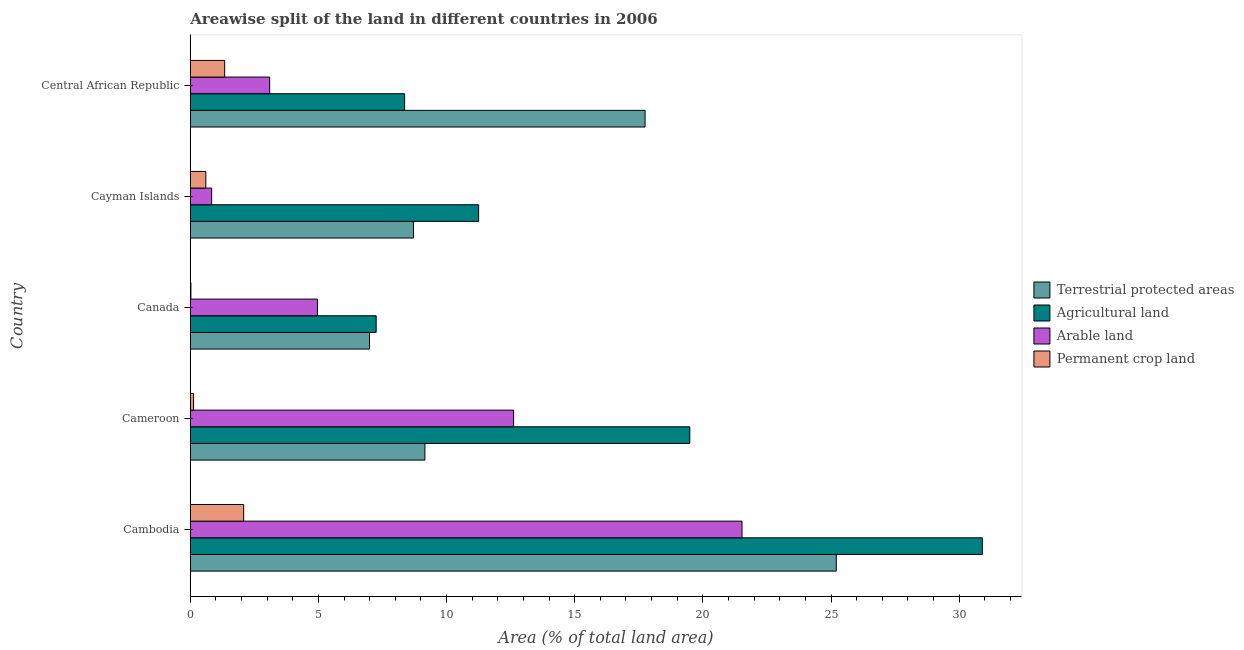Are the number of bars per tick equal to the number of legend labels?
Provide a short and direct response. Yes. Are the number of bars on each tick of the Y-axis equal?
Provide a succinct answer. Yes. What is the label of the 3rd group of bars from the top?
Make the answer very short. Canada. What is the percentage of area under arable land in Cameroon?
Provide a short and direct response. 12.61. Across all countries, what is the maximum percentage of land under terrestrial protection?
Provide a succinct answer. 25.21. Across all countries, what is the minimum percentage of area under permanent crop land?
Offer a very short reply. 0.02. In which country was the percentage of area under permanent crop land maximum?
Your answer should be compact. Cambodia. In which country was the percentage of area under arable land minimum?
Keep it short and to the point. Cayman Islands. What is the total percentage of area under arable land in the graph?
Keep it short and to the point. 43.03. What is the difference between the percentage of land under terrestrial protection in Cameroon and that in Cayman Islands?
Provide a succinct answer. 0.44. What is the difference between the percentage of area under arable land in Cameroon and the percentage of area under agricultural land in Central African Republic?
Make the answer very short. 4.25. What is the average percentage of land under terrestrial protection per country?
Offer a terse response. 13.56. What is the difference between the percentage of area under arable land and percentage of area under agricultural land in Canada?
Keep it short and to the point. -2.29. What is the ratio of the percentage of land under terrestrial protection in Cambodia to that in Cayman Islands?
Give a very brief answer. 2.89. What is the difference between the highest and the second highest percentage of land under terrestrial protection?
Your response must be concise. 7.46. What is the difference between the highest and the lowest percentage of area under permanent crop land?
Ensure brevity in your answer.  2.06. In how many countries, is the percentage of area under arable land greater than the average percentage of area under arable land taken over all countries?
Your answer should be very brief. 2. Is it the case that in every country, the sum of the percentage of area under agricultural land and percentage of land under terrestrial protection is greater than the sum of percentage of area under permanent crop land and percentage of area under arable land?
Offer a very short reply. No. What does the 4th bar from the top in Canada represents?
Offer a terse response. Terrestrial protected areas. What does the 4th bar from the bottom in Cayman Islands represents?
Keep it short and to the point. Permanent crop land. What is the difference between two consecutive major ticks on the X-axis?
Give a very brief answer. 5. Are the values on the major ticks of X-axis written in scientific E-notation?
Make the answer very short. No. Does the graph contain grids?
Offer a very short reply. No. Where does the legend appear in the graph?
Keep it short and to the point. Center right. How many legend labels are there?
Your answer should be very brief. 4. How are the legend labels stacked?
Give a very brief answer. Vertical. What is the title of the graph?
Offer a very short reply. Areawise split of the land in different countries in 2006. What is the label or title of the X-axis?
Give a very brief answer. Area (% of total land area). What is the Area (% of total land area) of Terrestrial protected areas in Cambodia?
Your answer should be compact. 25.21. What is the Area (% of total land area) of Agricultural land in Cambodia?
Your response must be concise. 30.9. What is the Area (% of total land area) of Arable land in Cambodia?
Ensure brevity in your answer.  21.53. What is the Area (% of total land area) of Permanent crop land in Cambodia?
Provide a succinct answer. 2.08. What is the Area (% of total land area) of Terrestrial protected areas in Cameroon?
Provide a succinct answer. 9.15. What is the Area (% of total land area) in Agricultural land in Cameroon?
Your answer should be compact. 19.49. What is the Area (% of total land area) in Arable land in Cameroon?
Provide a succinct answer. 12.61. What is the Area (% of total land area) of Permanent crop land in Cameroon?
Give a very brief answer. 0.13. What is the Area (% of total land area) in Terrestrial protected areas in Canada?
Make the answer very short. 6.99. What is the Area (% of total land area) of Agricultural land in Canada?
Keep it short and to the point. 7.25. What is the Area (% of total land area) in Arable land in Canada?
Offer a terse response. 4.96. What is the Area (% of total land area) in Permanent crop land in Canada?
Give a very brief answer. 0.02. What is the Area (% of total land area) of Terrestrial protected areas in Cayman Islands?
Offer a terse response. 8.71. What is the Area (% of total land area) in Agricultural land in Cayman Islands?
Keep it short and to the point. 11.25. What is the Area (% of total land area) of Arable land in Cayman Islands?
Your response must be concise. 0.83. What is the Area (% of total land area) of Permanent crop land in Cayman Islands?
Provide a short and direct response. 0.61. What is the Area (% of total land area) of Terrestrial protected areas in Central African Republic?
Offer a very short reply. 17.74. What is the Area (% of total land area) in Agricultural land in Central African Republic?
Provide a short and direct response. 8.36. What is the Area (% of total land area) in Arable land in Central African Republic?
Your response must be concise. 3.1. What is the Area (% of total land area) in Permanent crop land in Central African Republic?
Make the answer very short. 1.34. Across all countries, what is the maximum Area (% of total land area) of Terrestrial protected areas?
Ensure brevity in your answer.  25.21. Across all countries, what is the maximum Area (% of total land area) of Agricultural land?
Provide a short and direct response. 30.9. Across all countries, what is the maximum Area (% of total land area) of Arable land?
Offer a very short reply. 21.53. Across all countries, what is the maximum Area (% of total land area) of Permanent crop land?
Your answer should be very brief. 2.08. Across all countries, what is the minimum Area (% of total land area) of Terrestrial protected areas?
Provide a succinct answer. 6.99. Across all countries, what is the minimum Area (% of total land area) of Agricultural land?
Offer a very short reply. 7.25. Across all countries, what is the minimum Area (% of total land area) in Arable land?
Keep it short and to the point. 0.83. Across all countries, what is the minimum Area (% of total land area) in Permanent crop land?
Make the answer very short. 0.02. What is the total Area (% of total land area) of Terrestrial protected areas in the graph?
Make the answer very short. 67.81. What is the total Area (% of total land area) of Agricultural land in the graph?
Offer a very short reply. 77.26. What is the total Area (% of total land area) of Arable land in the graph?
Ensure brevity in your answer.  43.03. What is the total Area (% of total land area) of Permanent crop land in the graph?
Your answer should be compact. 4.18. What is the difference between the Area (% of total land area) in Terrestrial protected areas in Cambodia and that in Cameroon?
Provide a short and direct response. 16.05. What is the difference between the Area (% of total land area) of Agricultural land in Cambodia and that in Cameroon?
Give a very brief answer. 11.41. What is the difference between the Area (% of total land area) of Arable land in Cambodia and that in Cameroon?
Your answer should be compact. 8.91. What is the difference between the Area (% of total land area) in Permanent crop land in Cambodia and that in Cameroon?
Make the answer very short. 1.95. What is the difference between the Area (% of total land area) of Terrestrial protected areas in Cambodia and that in Canada?
Keep it short and to the point. 18.21. What is the difference between the Area (% of total land area) of Agricultural land in Cambodia and that in Canada?
Keep it short and to the point. 23.65. What is the difference between the Area (% of total land area) in Arable land in Cambodia and that in Canada?
Your answer should be very brief. 16.57. What is the difference between the Area (% of total land area) of Permanent crop land in Cambodia and that in Canada?
Your answer should be compact. 2.06. What is the difference between the Area (% of total land area) of Terrestrial protected areas in Cambodia and that in Cayman Islands?
Give a very brief answer. 16.5. What is the difference between the Area (% of total land area) in Agricultural land in Cambodia and that in Cayman Islands?
Give a very brief answer. 19.65. What is the difference between the Area (% of total land area) in Arable land in Cambodia and that in Cayman Islands?
Ensure brevity in your answer.  20.69. What is the difference between the Area (% of total land area) in Permanent crop land in Cambodia and that in Cayman Islands?
Keep it short and to the point. 1.48. What is the difference between the Area (% of total land area) in Terrestrial protected areas in Cambodia and that in Central African Republic?
Your answer should be compact. 7.46. What is the difference between the Area (% of total land area) of Agricultural land in Cambodia and that in Central African Republic?
Your response must be concise. 22.54. What is the difference between the Area (% of total land area) in Arable land in Cambodia and that in Central African Republic?
Give a very brief answer. 18.43. What is the difference between the Area (% of total land area) in Permanent crop land in Cambodia and that in Central African Republic?
Your answer should be very brief. 0.74. What is the difference between the Area (% of total land area) of Terrestrial protected areas in Cameroon and that in Canada?
Your answer should be compact. 2.16. What is the difference between the Area (% of total land area) of Agricultural land in Cameroon and that in Canada?
Offer a terse response. 12.24. What is the difference between the Area (% of total land area) in Arable land in Cameroon and that in Canada?
Give a very brief answer. 7.65. What is the difference between the Area (% of total land area) of Permanent crop land in Cameroon and that in Canada?
Give a very brief answer. 0.1. What is the difference between the Area (% of total land area) of Terrestrial protected areas in Cameroon and that in Cayman Islands?
Provide a succinct answer. 0.44. What is the difference between the Area (% of total land area) in Agricultural land in Cameroon and that in Cayman Islands?
Your response must be concise. 8.24. What is the difference between the Area (% of total land area) in Arable land in Cameroon and that in Cayman Islands?
Offer a terse response. 11.78. What is the difference between the Area (% of total land area) in Permanent crop land in Cameroon and that in Cayman Islands?
Provide a succinct answer. -0.48. What is the difference between the Area (% of total land area) of Terrestrial protected areas in Cameroon and that in Central African Republic?
Your response must be concise. -8.59. What is the difference between the Area (% of total land area) of Agricultural land in Cameroon and that in Central African Republic?
Offer a terse response. 11.13. What is the difference between the Area (% of total land area) of Arable land in Cameroon and that in Central African Republic?
Make the answer very short. 9.52. What is the difference between the Area (% of total land area) in Permanent crop land in Cameroon and that in Central African Republic?
Your answer should be compact. -1.21. What is the difference between the Area (% of total land area) of Terrestrial protected areas in Canada and that in Cayman Islands?
Offer a terse response. -1.72. What is the difference between the Area (% of total land area) of Agricultural land in Canada and that in Cayman Islands?
Provide a short and direct response. -4. What is the difference between the Area (% of total land area) in Arable land in Canada and that in Cayman Islands?
Your response must be concise. 4.13. What is the difference between the Area (% of total land area) in Permanent crop land in Canada and that in Cayman Islands?
Offer a terse response. -0.58. What is the difference between the Area (% of total land area) in Terrestrial protected areas in Canada and that in Central African Republic?
Make the answer very short. -10.75. What is the difference between the Area (% of total land area) in Agricultural land in Canada and that in Central African Republic?
Your answer should be very brief. -1.11. What is the difference between the Area (% of total land area) in Arable land in Canada and that in Central African Republic?
Your response must be concise. 1.86. What is the difference between the Area (% of total land area) in Permanent crop land in Canada and that in Central African Republic?
Your answer should be compact. -1.32. What is the difference between the Area (% of total land area) in Terrestrial protected areas in Cayman Islands and that in Central African Republic?
Your answer should be compact. -9.03. What is the difference between the Area (% of total land area) of Agricultural land in Cayman Islands and that in Central African Republic?
Give a very brief answer. 2.89. What is the difference between the Area (% of total land area) in Arable land in Cayman Islands and that in Central African Republic?
Provide a succinct answer. -2.26. What is the difference between the Area (% of total land area) in Permanent crop land in Cayman Islands and that in Central African Republic?
Give a very brief answer. -0.74. What is the difference between the Area (% of total land area) in Terrestrial protected areas in Cambodia and the Area (% of total land area) in Agricultural land in Cameroon?
Provide a short and direct response. 5.72. What is the difference between the Area (% of total land area) of Terrestrial protected areas in Cambodia and the Area (% of total land area) of Arable land in Cameroon?
Offer a very short reply. 12.59. What is the difference between the Area (% of total land area) of Terrestrial protected areas in Cambodia and the Area (% of total land area) of Permanent crop land in Cameroon?
Your answer should be very brief. 25.08. What is the difference between the Area (% of total land area) in Agricultural land in Cambodia and the Area (% of total land area) in Arable land in Cameroon?
Make the answer very short. 18.29. What is the difference between the Area (% of total land area) of Agricultural land in Cambodia and the Area (% of total land area) of Permanent crop land in Cameroon?
Offer a very short reply. 30.77. What is the difference between the Area (% of total land area) in Arable land in Cambodia and the Area (% of total land area) in Permanent crop land in Cameroon?
Offer a very short reply. 21.4. What is the difference between the Area (% of total land area) of Terrestrial protected areas in Cambodia and the Area (% of total land area) of Agricultural land in Canada?
Offer a very short reply. 17.95. What is the difference between the Area (% of total land area) in Terrestrial protected areas in Cambodia and the Area (% of total land area) in Arable land in Canada?
Make the answer very short. 20.25. What is the difference between the Area (% of total land area) of Terrestrial protected areas in Cambodia and the Area (% of total land area) of Permanent crop land in Canada?
Your answer should be compact. 25.18. What is the difference between the Area (% of total land area) of Agricultural land in Cambodia and the Area (% of total land area) of Arable land in Canada?
Your answer should be compact. 25.94. What is the difference between the Area (% of total land area) of Agricultural land in Cambodia and the Area (% of total land area) of Permanent crop land in Canada?
Your response must be concise. 30.88. What is the difference between the Area (% of total land area) in Arable land in Cambodia and the Area (% of total land area) in Permanent crop land in Canada?
Your response must be concise. 21.5. What is the difference between the Area (% of total land area) in Terrestrial protected areas in Cambodia and the Area (% of total land area) in Agricultural land in Cayman Islands?
Make the answer very short. 13.96. What is the difference between the Area (% of total land area) of Terrestrial protected areas in Cambodia and the Area (% of total land area) of Arable land in Cayman Islands?
Keep it short and to the point. 24.37. What is the difference between the Area (% of total land area) of Terrestrial protected areas in Cambodia and the Area (% of total land area) of Permanent crop land in Cayman Islands?
Provide a short and direct response. 24.6. What is the difference between the Area (% of total land area) of Agricultural land in Cambodia and the Area (% of total land area) of Arable land in Cayman Islands?
Offer a very short reply. 30.07. What is the difference between the Area (% of total land area) in Agricultural land in Cambodia and the Area (% of total land area) in Permanent crop land in Cayman Islands?
Offer a terse response. 30.3. What is the difference between the Area (% of total land area) in Arable land in Cambodia and the Area (% of total land area) in Permanent crop land in Cayman Islands?
Offer a very short reply. 20.92. What is the difference between the Area (% of total land area) in Terrestrial protected areas in Cambodia and the Area (% of total land area) in Agricultural land in Central African Republic?
Give a very brief answer. 16.84. What is the difference between the Area (% of total land area) in Terrestrial protected areas in Cambodia and the Area (% of total land area) in Arable land in Central African Republic?
Your response must be concise. 22.11. What is the difference between the Area (% of total land area) of Terrestrial protected areas in Cambodia and the Area (% of total land area) of Permanent crop land in Central African Republic?
Your answer should be compact. 23.86. What is the difference between the Area (% of total land area) of Agricultural land in Cambodia and the Area (% of total land area) of Arable land in Central African Republic?
Give a very brief answer. 27.8. What is the difference between the Area (% of total land area) in Agricultural land in Cambodia and the Area (% of total land area) in Permanent crop land in Central African Republic?
Make the answer very short. 29.56. What is the difference between the Area (% of total land area) in Arable land in Cambodia and the Area (% of total land area) in Permanent crop land in Central African Republic?
Your answer should be very brief. 20.19. What is the difference between the Area (% of total land area) in Terrestrial protected areas in Cameroon and the Area (% of total land area) in Agricultural land in Canada?
Provide a succinct answer. 1.9. What is the difference between the Area (% of total land area) of Terrestrial protected areas in Cameroon and the Area (% of total land area) of Arable land in Canada?
Offer a terse response. 4.19. What is the difference between the Area (% of total land area) in Terrestrial protected areas in Cameroon and the Area (% of total land area) in Permanent crop land in Canada?
Provide a succinct answer. 9.13. What is the difference between the Area (% of total land area) of Agricultural land in Cameroon and the Area (% of total land area) of Arable land in Canada?
Your answer should be compact. 14.53. What is the difference between the Area (% of total land area) of Agricultural land in Cameroon and the Area (% of total land area) of Permanent crop land in Canada?
Provide a short and direct response. 19.47. What is the difference between the Area (% of total land area) in Arable land in Cameroon and the Area (% of total land area) in Permanent crop land in Canada?
Offer a terse response. 12.59. What is the difference between the Area (% of total land area) in Terrestrial protected areas in Cameroon and the Area (% of total land area) in Agricultural land in Cayman Islands?
Keep it short and to the point. -2.1. What is the difference between the Area (% of total land area) in Terrestrial protected areas in Cameroon and the Area (% of total land area) in Arable land in Cayman Islands?
Your answer should be compact. 8.32. What is the difference between the Area (% of total land area) of Terrestrial protected areas in Cameroon and the Area (% of total land area) of Permanent crop land in Cayman Islands?
Your response must be concise. 8.55. What is the difference between the Area (% of total land area) in Agricultural land in Cameroon and the Area (% of total land area) in Arable land in Cayman Islands?
Give a very brief answer. 18.66. What is the difference between the Area (% of total land area) in Agricultural land in Cameroon and the Area (% of total land area) in Permanent crop land in Cayman Islands?
Your response must be concise. 18.88. What is the difference between the Area (% of total land area) of Arable land in Cameroon and the Area (% of total land area) of Permanent crop land in Cayman Islands?
Your answer should be compact. 12.01. What is the difference between the Area (% of total land area) of Terrestrial protected areas in Cameroon and the Area (% of total land area) of Agricultural land in Central African Republic?
Give a very brief answer. 0.79. What is the difference between the Area (% of total land area) of Terrestrial protected areas in Cameroon and the Area (% of total land area) of Arable land in Central African Republic?
Give a very brief answer. 6.06. What is the difference between the Area (% of total land area) of Terrestrial protected areas in Cameroon and the Area (% of total land area) of Permanent crop land in Central African Republic?
Provide a succinct answer. 7.81. What is the difference between the Area (% of total land area) in Agricultural land in Cameroon and the Area (% of total land area) in Arable land in Central African Republic?
Keep it short and to the point. 16.39. What is the difference between the Area (% of total land area) in Agricultural land in Cameroon and the Area (% of total land area) in Permanent crop land in Central African Republic?
Your answer should be compact. 18.15. What is the difference between the Area (% of total land area) in Arable land in Cameroon and the Area (% of total land area) in Permanent crop land in Central African Republic?
Offer a very short reply. 11.27. What is the difference between the Area (% of total land area) of Terrestrial protected areas in Canada and the Area (% of total land area) of Agricultural land in Cayman Islands?
Your answer should be very brief. -4.26. What is the difference between the Area (% of total land area) of Terrestrial protected areas in Canada and the Area (% of total land area) of Arable land in Cayman Islands?
Provide a succinct answer. 6.16. What is the difference between the Area (% of total land area) of Terrestrial protected areas in Canada and the Area (% of total land area) of Permanent crop land in Cayman Islands?
Ensure brevity in your answer.  6.39. What is the difference between the Area (% of total land area) in Agricultural land in Canada and the Area (% of total land area) in Arable land in Cayman Islands?
Keep it short and to the point. 6.42. What is the difference between the Area (% of total land area) in Agricultural land in Canada and the Area (% of total land area) in Permanent crop land in Cayman Islands?
Keep it short and to the point. 6.65. What is the difference between the Area (% of total land area) of Arable land in Canada and the Area (% of total land area) of Permanent crop land in Cayman Islands?
Keep it short and to the point. 4.36. What is the difference between the Area (% of total land area) of Terrestrial protected areas in Canada and the Area (% of total land area) of Agricultural land in Central African Republic?
Offer a terse response. -1.37. What is the difference between the Area (% of total land area) in Terrestrial protected areas in Canada and the Area (% of total land area) in Arable land in Central African Republic?
Offer a very short reply. 3.89. What is the difference between the Area (% of total land area) in Terrestrial protected areas in Canada and the Area (% of total land area) in Permanent crop land in Central African Republic?
Offer a very short reply. 5.65. What is the difference between the Area (% of total land area) of Agricultural land in Canada and the Area (% of total land area) of Arable land in Central African Republic?
Offer a very short reply. 4.15. What is the difference between the Area (% of total land area) in Agricultural land in Canada and the Area (% of total land area) in Permanent crop land in Central African Republic?
Your answer should be compact. 5.91. What is the difference between the Area (% of total land area) of Arable land in Canada and the Area (% of total land area) of Permanent crop land in Central African Republic?
Keep it short and to the point. 3.62. What is the difference between the Area (% of total land area) in Terrestrial protected areas in Cayman Islands and the Area (% of total land area) in Agricultural land in Central African Republic?
Keep it short and to the point. 0.35. What is the difference between the Area (% of total land area) of Terrestrial protected areas in Cayman Islands and the Area (% of total land area) of Arable land in Central African Republic?
Offer a terse response. 5.61. What is the difference between the Area (% of total land area) in Terrestrial protected areas in Cayman Islands and the Area (% of total land area) in Permanent crop land in Central African Republic?
Ensure brevity in your answer.  7.37. What is the difference between the Area (% of total land area) of Agricultural land in Cayman Islands and the Area (% of total land area) of Arable land in Central African Republic?
Provide a short and direct response. 8.15. What is the difference between the Area (% of total land area) in Agricultural land in Cayman Islands and the Area (% of total land area) in Permanent crop land in Central African Republic?
Keep it short and to the point. 9.91. What is the difference between the Area (% of total land area) in Arable land in Cayman Islands and the Area (% of total land area) in Permanent crop land in Central African Republic?
Provide a succinct answer. -0.51. What is the average Area (% of total land area) in Terrestrial protected areas per country?
Give a very brief answer. 13.56. What is the average Area (% of total land area) in Agricultural land per country?
Make the answer very short. 15.45. What is the average Area (% of total land area) in Arable land per country?
Provide a short and direct response. 8.61. What is the average Area (% of total land area) of Permanent crop land per country?
Provide a short and direct response. 0.84. What is the difference between the Area (% of total land area) of Terrestrial protected areas and Area (% of total land area) of Agricultural land in Cambodia?
Your answer should be very brief. -5.7. What is the difference between the Area (% of total land area) of Terrestrial protected areas and Area (% of total land area) of Arable land in Cambodia?
Your answer should be very brief. 3.68. What is the difference between the Area (% of total land area) of Terrestrial protected areas and Area (% of total land area) of Permanent crop land in Cambodia?
Provide a short and direct response. 23.12. What is the difference between the Area (% of total land area) of Agricultural land and Area (% of total land area) of Arable land in Cambodia?
Give a very brief answer. 9.38. What is the difference between the Area (% of total land area) in Agricultural land and Area (% of total land area) in Permanent crop land in Cambodia?
Keep it short and to the point. 28.82. What is the difference between the Area (% of total land area) of Arable land and Area (% of total land area) of Permanent crop land in Cambodia?
Ensure brevity in your answer.  19.44. What is the difference between the Area (% of total land area) of Terrestrial protected areas and Area (% of total land area) of Agricultural land in Cameroon?
Your answer should be compact. -10.34. What is the difference between the Area (% of total land area) of Terrestrial protected areas and Area (% of total land area) of Arable land in Cameroon?
Provide a succinct answer. -3.46. What is the difference between the Area (% of total land area) in Terrestrial protected areas and Area (% of total land area) in Permanent crop land in Cameroon?
Provide a succinct answer. 9.03. What is the difference between the Area (% of total land area) in Agricultural land and Area (% of total land area) in Arable land in Cameroon?
Offer a very short reply. 6.88. What is the difference between the Area (% of total land area) in Agricultural land and Area (% of total land area) in Permanent crop land in Cameroon?
Offer a terse response. 19.36. What is the difference between the Area (% of total land area) of Arable land and Area (% of total land area) of Permanent crop land in Cameroon?
Provide a succinct answer. 12.49. What is the difference between the Area (% of total land area) in Terrestrial protected areas and Area (% of total land area) in Agricultural land in Canada?
Offer a terse response. -0.26. What is the difference between the Area (% of total land area) in Terrestrial protected areas and Area (% of total land area) in Arable land in Canada?
Your answer should be compact. 2.03. What is the difference between the Area (% of total land area) of Terrestrial protected areas and Area (% of total land area) of Permanent crop land in Canada?
Your answer should be compact. 6.97. What is the difference between the Area (% of total land area) of Agricultural land and Area (% of total land area) of Arable land in Canada?
Keep it short and to the point. 2.29. What is the difference between the Area (% of total land area) in Agricultural land and Area (% of total land area) in Permanent crop land in Canada?
Offer a very short reply. 7.23. What is the difference between the Area (% of total land area) of Arable land and Area (% of total land area) of Permanent crop land in Canada?
Your response must be concise. 4.94. What is the difference between the Area (% of total land area) of Terrestrial protected areas and Area (% of total land area) of Agricultural land in Cayman Islands?
Make the answer very short. -2.54. What is the difference between the Area (% of total land area) of Terrestrial protected areas and Area (% of total land area) of Arable land in Cayman Islands?
Make the answer very short. 7.88. What is the difference between the Area (% of total land area) in Terrestrial protected areas and Area (% of total land area) in Permanent crop land in Cayman Islands?
Ensure brevity in your answer.  8.11. What is the difference between the Area (% of total land area) of Agricultural land and Area (% of total land area) of Arable land in Cayman Islands?
Your answer should be compact. 10.42. What is the difference between the Area (% of total land area) of Agricultural land and Area (% of total land area) of Permanent crop land in Cayman Islands?
Provide a succinct answer. 10.64. What is the difference between the Area (% of total land area) in Arable land and Area (% of total land area) in Permanent crop land in Cayman Islands?
Offer a very short reply. 0.23. What is the difference between the Area (% of total land area) in Terrestrial protected areas and Area (% of total land area) in Agricultural land in Central African Republic?
Offer a terse response. 9.38. What is the difference between the Area (% of total land area) in Terrestrial protected areas and Area (% of total land area) in Arable land in Central African Republic?
Ensure brevity in your answer.  14.65. What is the difference between the Area (% of total land area) of Terrestrial protected areas and Area (% of total land area) of Permanent crop land in Central African Republic?
Provide a succinct answer. 16.4. What is the difference between the Area (% of total land area) in Agricultural land and Area (% of total land area) in Arable land in Central African Republic?
Provide a short and direct response. 5.26. What is the difference between the Area (% of total land area) of Agricultural land and Area (% of total land area) of Permanent crop land in Central African Republic?
Make the answer very short. 7.02. What is the difference between the Area (% of total land area) in Arable land and Area (% of total land area) in Permanent crop land in Central African Republic?
Make the answer very short. 1.76. What is the ratio of the Area (% of total land area) of Terrestrial protected areas in Cambodia to that in Cameroon?
Give a very brief answer. 2.75. What is the ratio of the Area (% of total land area) of Agricultural land in Cambodia to that in Cameroon?
Make the answer very short. 1.59. What is the ratio of the Area (% of total land area) in Arable land in Cambodia to that in Cameroon?
Your answer should be very brief. 1.71. What is the ratio of the Area (% of total land area) of Permanent crop land in Cambodia to that in Cameroon?
Your answer should be compact. 16.22. What is the ratio of the Area (% of total land area) in Terrestrial protected areas in Cambodia to that in Canada?
Your response must be concise. 3.6. What is the ratio of the Area (% of total land area) in Agricultural land in Cambodia to that in Canada?
Keep it short and to the point. 4.26. What is the ratio of the Area (% of total land area) in Arable land in Cambodia to that in Canada?
Offer a very short reply. 4.34. What is the ratio of the Area (% of total land area) of Permanent crop land in Cambodia to that in Canada?
Provide a succinct answer. 87.44. What is the ratio of the Area (% of total land area) of Terrestrial protected areas in Cambodia to that in Cayman Islands?
Give a very brief answer. 2.89. What is the ratio of the Area (% of total land area) of Agricultural land in Cambodia to that in Cayman Islands?
Provide a short and direct response. 2.75. What is the ratio of the Area (% of total land area) of Arable land in Cambodia to that in Cayman Islands?
Give a very brief answer. 25.83. What is the ratio of the Area (% of total land area) in Permanent crop land in Cambodia to that in Cayman Islands?
Make the answer very short. 3.44. What is the ratio of the Area (% of total land area) of Terrestrial protected areas in Cambodia to that in Central African Republic?
Provide a succinct answer. 1.42. What is the ratio of the Area (% of total land area) in Agricultural land in Cambodia to that in Central African Republic?
Provide a short and direct response. 3.7. What is the ratio of the Area (% of total land area) in Arable land in Cambodia to that in Central African Republic?
Give a very brief answer. 6.95. What is the ratio of the Area (% of total land area) in Permanent crop land in Cambodia to that in Central African Republic?
Your answer should be compact. 1.55. What is the ratio of the Area (% of total land area) in Terrestrial protected areas in Cameroon to that in Canada?
Provide a succinct answer. 1.31. What is the ratio of the Area (% of total land area) of Agricultural land in Cameroon to that in Canada?
Offer a terse response. 2.69. What is the ratio of the Area (% of total land area) of Arable land in Cameroon to that in Canada?
Ensure brevity in your answer.  2.54. What is the ratio of the Area (% of total land area) of Permanent crop land in Cameroon to that in Canada?
Make the answer very short. 5.39. What is the ratio of the Area (% of total land area) of Terrestrial protected areas in Cameroon to that in Cayman Islands?
Ensure brevity in your answer.  1.05. What is the ratio of the Area (% of total land area) of Agricultural land in Cameroon to that in Cayman Islands?
Give a very brief answer. 1.73. What is the ratio of the Area (% of total land area) of Arable land in Cameroon to that in Cayman Islands?
Offer a very short reply. 15.14. What is the ratio of the Area (% of total land area) of Permanent crop land in Cameroon to that in Cayman Islands?
Your answer should be compact. 0.21. What is the ratio of the Area (% of total land area) of Terrestrial protected areas in Cameroon to that in Central African Republic?
Your answer should be compact. 0.52. What is the ratio of the Area (% of total land area) in Agricultural land in Cameroon to that in Central African Republic?
Ensure brevity in your answer.  2.33. What is the ratio of the Area (% of total land area) of Arable land in Cameroon to that in Central African Republic?
Give a very brief answer. 4.07. What is the ratio of the Area (% of total land area) in Permanent crop land in Cameroon to that in Central African Republic?
Provide a succinct answer. 0.1. What is the ratio of the Area (% of total land area) of Terrestrial protected areas in Canada to that in Cayman Islands?
Keep it short and to the point. 0.8. What is the ratio of the Area (% of total land area) in Agricultural land in Canada to that in Cayman Islands?
Offer a terse response. 0.64. What is the ratio of the Area (% of total land area) in Arable land in Canada to that in Cayman Islands?
Your response must be concise. 5.95. What is the ratio of the Area (% of total land area) of Permanent crop land in Canada to that in Cayman Islands?
Your answer should be very brief. 0.04. What is the ratio of the Area (% of total land area) of Terrestrial protected areas in Canada to that in Central African Republic?
Keep it short and to the point. 0.39. What is the ratio of the Area (% of total land area) of Agricultural land in Canada to that in Central African Republic?
Provide a succinct answer. 0.87. What is the ratio of the Area (% of total land area) in Arable land in Canada to that in Central African Republic?
Offer a terse response. 1.6. What is the ratio of the Area (% of total land area) of Permanent crop land in Canada to that in Central African Republic?
Ensure brevity in your answer.  0.02. What is the ratio of the Area (% of total land area) in Terrestrial protected areas in Cayman Islands to that in Central African Republic?
Offer a terse response. 0.49. What is the ratio of the Area (% of total land area) of Agricultural land in Cayman Islands to that in Central African Republic?
Give a very brief answer. 1.35. What is the ratio of the Area (% of total land area) in Arable land in Cayman Islands to that in Central African Republic?
Offer a very short reply. 0.27. What is the ratio of the Area (% of total land area) in Permanent crop land in Cayman Islands to that in Central African Republic?
Your answer should be compact. 0.45. What is the difference between the highest and the second highest Area (% of total land area) of Terrestrial protected areas?
Your answer should be very brief. 7.46. What is the difference between the highest and the second highest Area (% of total land area) in Agricultural land?
Provide a short and direct response. 11.41. What is the difference between the highest and the second highest Area (% of total land area) of Arable land?
Provide a succinct answer. 8.91. What is the difference between the highest and the second highest Area (% of total land area) of Permanent crop land?
Offer a terse response. 0.74. What is the difference between the highest and the lowest Area (% of total land area) of Terrestrial protected areas?
Keep it short and to the point. 18.21. What is the difference between the highest and the lowest Area (% of total land area) in Agricultural land?
Keep it short and to the point. 23.65. What is the difference between the highest and the lowest Area (% of total land area) of Arable land?
Ensure brevity in your answer.  20.69. What is the difference between the highest and the lowest Area (% of total land area) in Permanent crop land?
Your response must be concise. 2.06. 